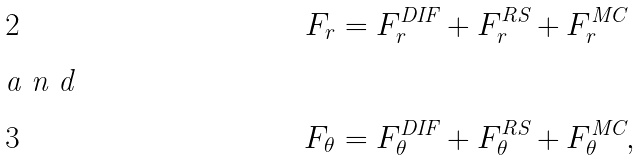<formula> <loc_0><loc_0><loc_500><loc_500>F _ { r } & = F _ { r } ^ { \text {DIF} } + F _ { r } ^ { \text {RS} } + F _ { r } ^ { \text {MC} } \\ \intertext { a n d } F _ { \theta } & = F _ { \theta } ^ { \text {DIF} } + F _ { \theta } ^ { \text {RS} } + F _ { \theta } ^ { \text {MC} } ,</formula> 